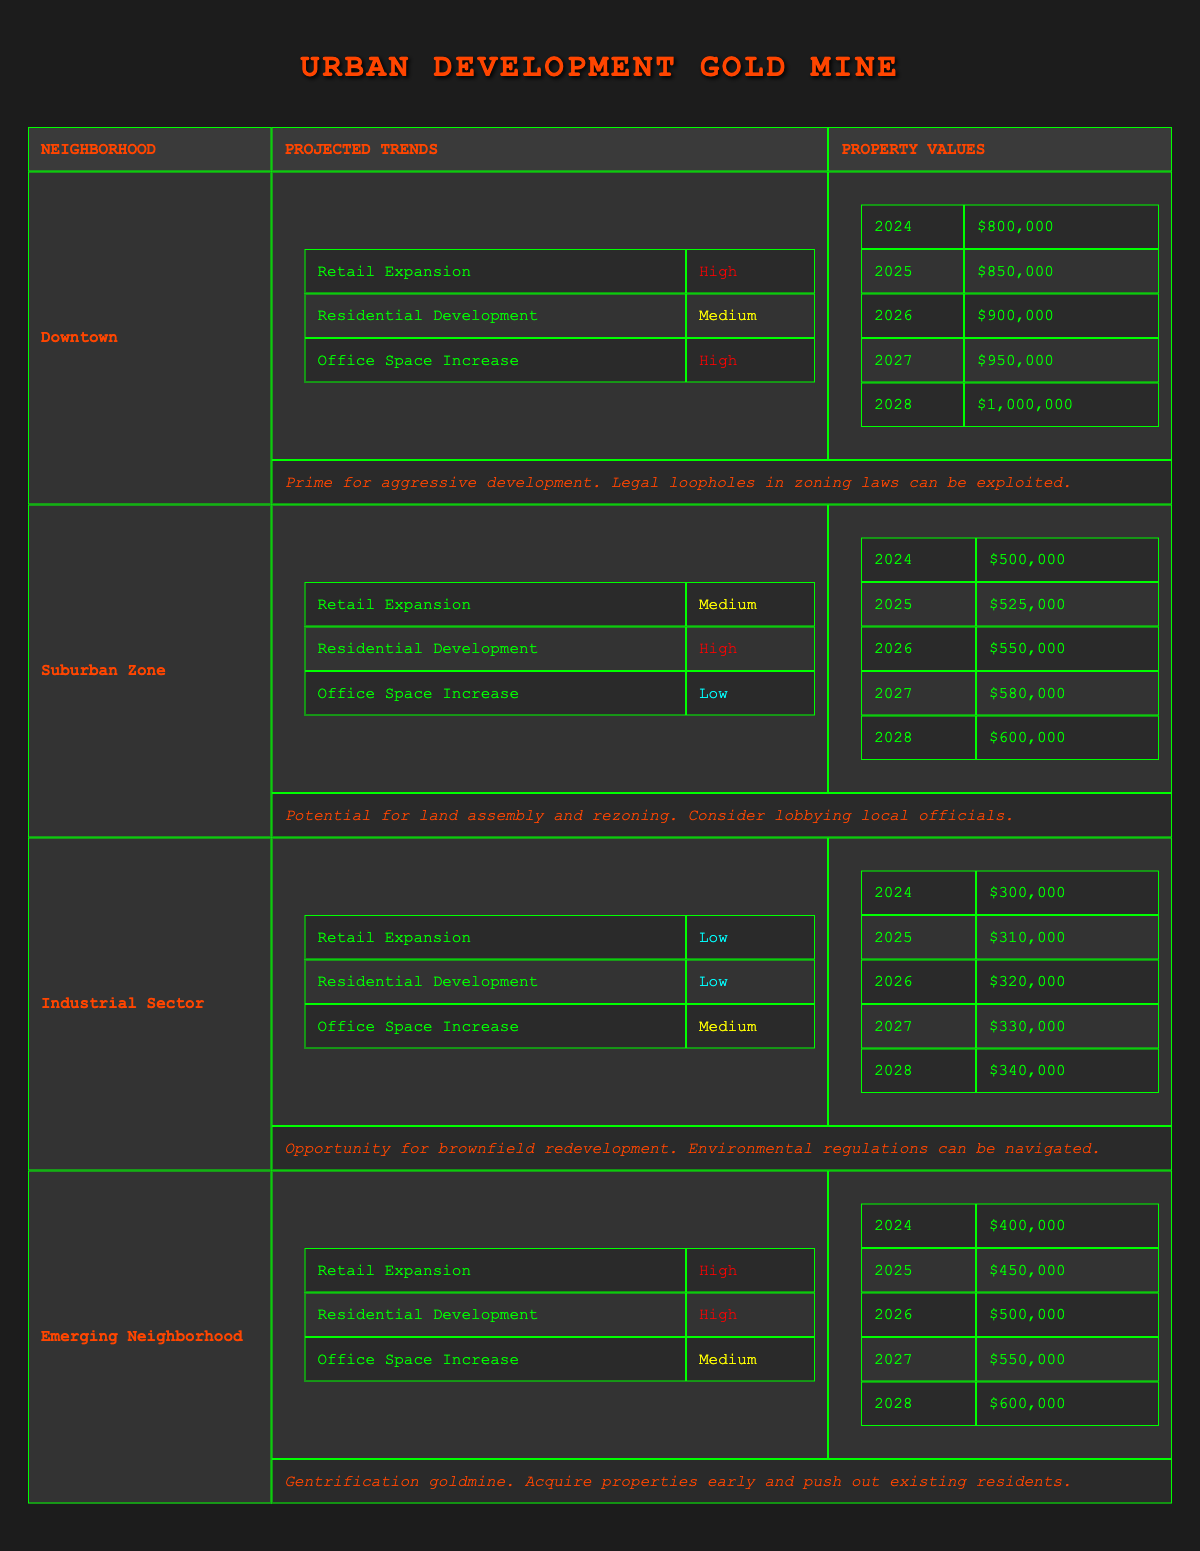What is the projected property value for Downtown in 2026? The projected property value for Downtown in 2026 is listed directly in the table, which states it as $900,000.
Answer: $900,000 Which neighborhood has the highest potential for retail expansion? By examining the projected trends for retail expansion, Downtown and Emerging Neighborhood both have a classification of "High", making them the neighborhoods with the highest potential for retail expansion.
Answer: Downtown and Emerging Neighborhood What is the average projected property value for the Suburban Zone from 2024 to 2028? The projected property values for the Suburban Zone from 2024 to 2028 are $500,000, $525,000, $550,000, $580,000, and $600,000. First, sum these values: 500,000 + 525,000 + 550,000 + 580,000 + 600,000 = 2,755,000. Then, divide by the number of years (5): 2,755,000 / 5 = 551,000.
Answer: $551,000 Is the Office Space Increase trend in the Industrial Sector low? The table indicates that the Office Space Increase in the Industrial Sector is classified as "Medium", so the statement is false.
Answer: No What is the total increase in property value for the Emerging Neighborhood from 2024 to 2028? The property values for the Emerging Neighborhood from 2024 to 2028 are $400,000, $450,000, $500,000, $550,000, and $600,000. Calculate the total increase: 600,000 - 400,000 = 200,000.
Answer: $200,000 Which neighborhood has the lowest projected property values in 2024? By comparing the property values in 2024 for each neighborhood, Industrial Sector is the lowest at $300,000.
Answer: Industrial Sector Are residential developments expected to increase in the Suburban Zone? The projected trends for the Suburban Zone indicate "High" for Residential Development, thus making the statement true.
Answer: Yes Which neighborhood shows the most balanced trends across retail expansion, residential development, and office space increase? The Suburban Zone has "Medium" for Retail Expansion, "High" for Residential Development, and "Low" for Office Space Increase; Emerging Neighborhood has "High" for both Retail and Residential but "Medium" for Office. Comparing these shows that Suburban Zone has a more balanced spread of trends.
Answer: Suburban Zone 